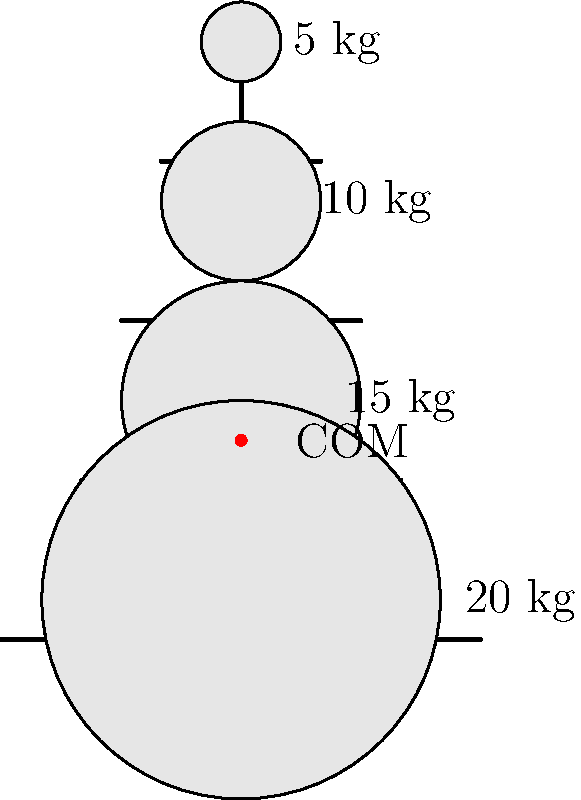A multi-tiered dessert display stand for a wedding reception consists of four circular tiers. The bottom tier weighs 20 kg, the second tier 15 kg, the third tier 10 kg, and the top tier 5 kg. If the center of mass of the entire structure is located 2.5 m above the base, what is the magnitude of the horizontal force $F$ required to tip the stand, assuming it pivots at the edge of its base? To solve this problem, we'll use the concept of torques and the condition for equilibrium. Let's approach this step-by-step:

1) First, we need to calculate the total weight of the stand:
   Total weight = 20 kg + 15 kg + 10 kg + 5 kg = 50 kg

2) The weight force acts downward at the center of mass, which is 2.5 m above the base. We'll use g = 9.8 m/s² for gravity.

3) The torque caused by the weight of the stand around the pivot point is:
   $τ_w = (50 \text{ kg})(9.8 \text{ m/s²})(3 \text{ m}) = 1470 \text{ N·m}$
   (Note: The horizontal distance from the pivot to the center of mass is half the width of the base, which is 3 m)

4) For the stand to be on the verge of tipping, the torque caused by the horizontal force F must be equal and opposite to the torque caused by the weight:
   $τ_F = F(2.5 \text{ m}) = 1470 \text{ N·m}$

5) Solving for F:
   $F = \frac{1470 \text{ N·m}}{2.5 \text{ m}} = 588 \text{ N}$

Therefore, a horizontal force of 588 N is required to tip the stand.
Answer: 588 N 